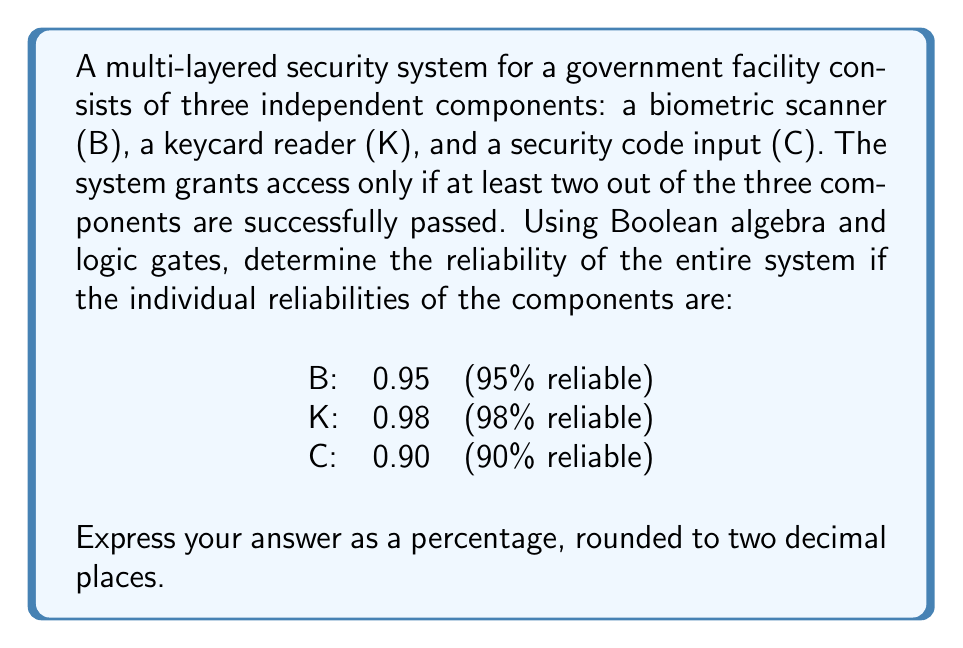Help me with this question. To solve this problem, we'll follow these steps:

1) First, let's express the system's logic using Boolean algebra. The system grants access when at least two components are successful, which can be represented as:

   $$(B \wedge K) \vee (B \wedge C) \vee (K \wedge C)$$

2) This Boolean expression corresponds to a Majority Logic Gate, also known as a "2-out-of-3" gate.

3) To calculate the reliability of the entire system, we need to find the probability that this Boolean expression is true. We can use the inclusion-exclusion principle:

   $$P(B \wedge K \vee B \wedge C \vee K \wedge C) = P(B \wedge K) + P(B \wedge C) + P(K \wedge C) - P(B \wedge K \wedge C)$$

4) Since the components are independent, we can multiply their individual probabilities:

   $$P(B \wedge K) = 0.95 \times 0.98 = 0.931$$
   $$P(B \wedge C) = 0.95 \times 0.90 = 0.855$$
   $$P(K \wedge C) = 0.98 \times 0.90 = 0.882$$
   $$P(B \wedge K \wedge C) = 0.95 \times 0.98 \times 0.90 = 0.8379$$

5) Now, let's substitute these values into our equation:

   $$P(\text{system works}) = 0.931 + 0.855 + 0.882 - 0.8379 = 1.8301$$

6) Therefore, the reliability of the entire system is 1.8301, or 183.01%.

7) However, probability cannot exceed 100%. This result occurs because we've double-counted some scenarios. To correct this, we need to subtract the probability of all components working:

   $$P(\text{corrected}) = P(B \vee K \vee C) = 1 - P(\overline{B} \wedge \overline{K} \wedge \overline{C})$$

8) Calculate $P(\overline{B} \wedge \overline{K} \wedge \overline{C})$:

   $$P(\overline{B} \wedge \overline{K} \wedge \overline{C}) = (1-0.95) \times (1-0.98) \times (1-0.90) = 0.05 \times 0.02 \times 0.10 = 0.0001$$

9) Therefore, the correct reliability is:

   $$P(\text{system works}) = 1 - 0.0001 = 0.9999$$

10) Convert to a percentage and round to two decimal places:

    $$0.9999 \times 100 = 99.99\%$$
Answer: 99.99% 